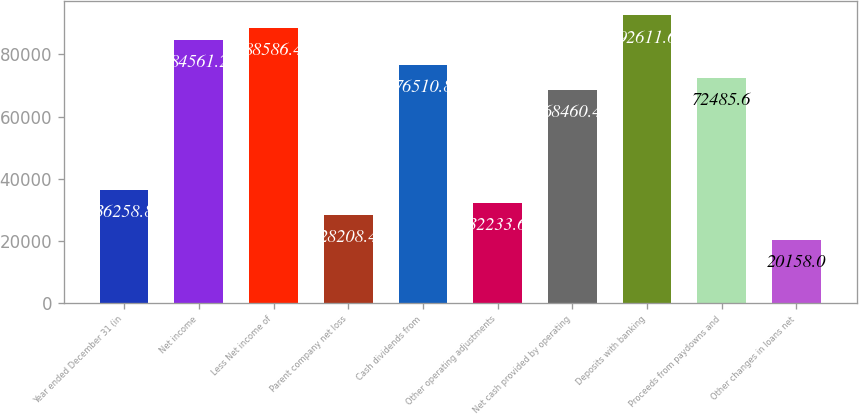Convert chart. <chart><loc_0><loc_0><loc_500><loc_500><bar_chart><fcel>Year ended December 31 (in<fcel>Net income<fcel>Less Net income of<fcel>Parent company net loss<fcel>Cash dividends from<fcel>Other operating adjustments<fcel>Net cash provided by operating<fcel>Deposits with banking<fcel>Proceeds from paydowns and<fcel>Other changes in loans net<nl><fcel>36258.8<fcel>84561.2<fcel>88586.4<fcel>28208.4<fcel>76510.8<fcel>32233.6<fcel>68460.4<fcel>92611.6<fcel>72485.6<fcel>20158<nl></chart> 